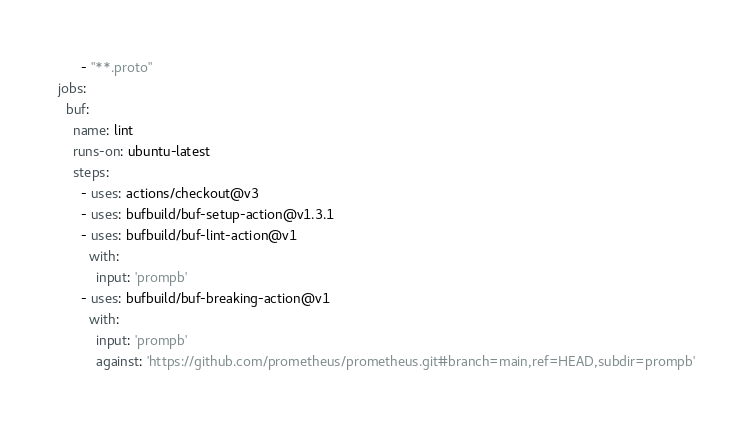Convert code to text. <code><loc_0><loc_0><loc_500><loc_500><_YAML_>      - "**.proto"
jobs:
  buf:
    name: lint
    runs-on: ubuntu-latest
    steps:
      - uses: actions/checkout@v3
      - uses: bufbuild/buf-setup-action@v1.3.1
      - uses: bufbuild/buf-lint-action@v1
        with:
          input: 'prompb'
      - uses: bufbuild/buf-breaking-action@v1
        with:
          input: 'prompb'
          against: 'https://github.com/prometheus/prometheus.git#branch=main,ref=HEAD,subdir=prompb'
</code> 